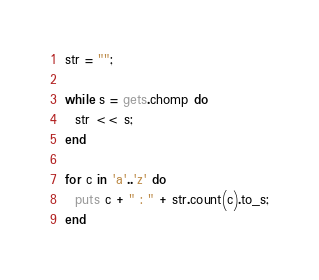Convert code to text. <code><loc_0><loc_0><loc_500><loc_500><_Ruby_>str = "";

while s = gets.chomp do
  str << s;
end

for c in 'a'..'z' do
  puts c + " : " + str.count(c).to_s;
end</code> 